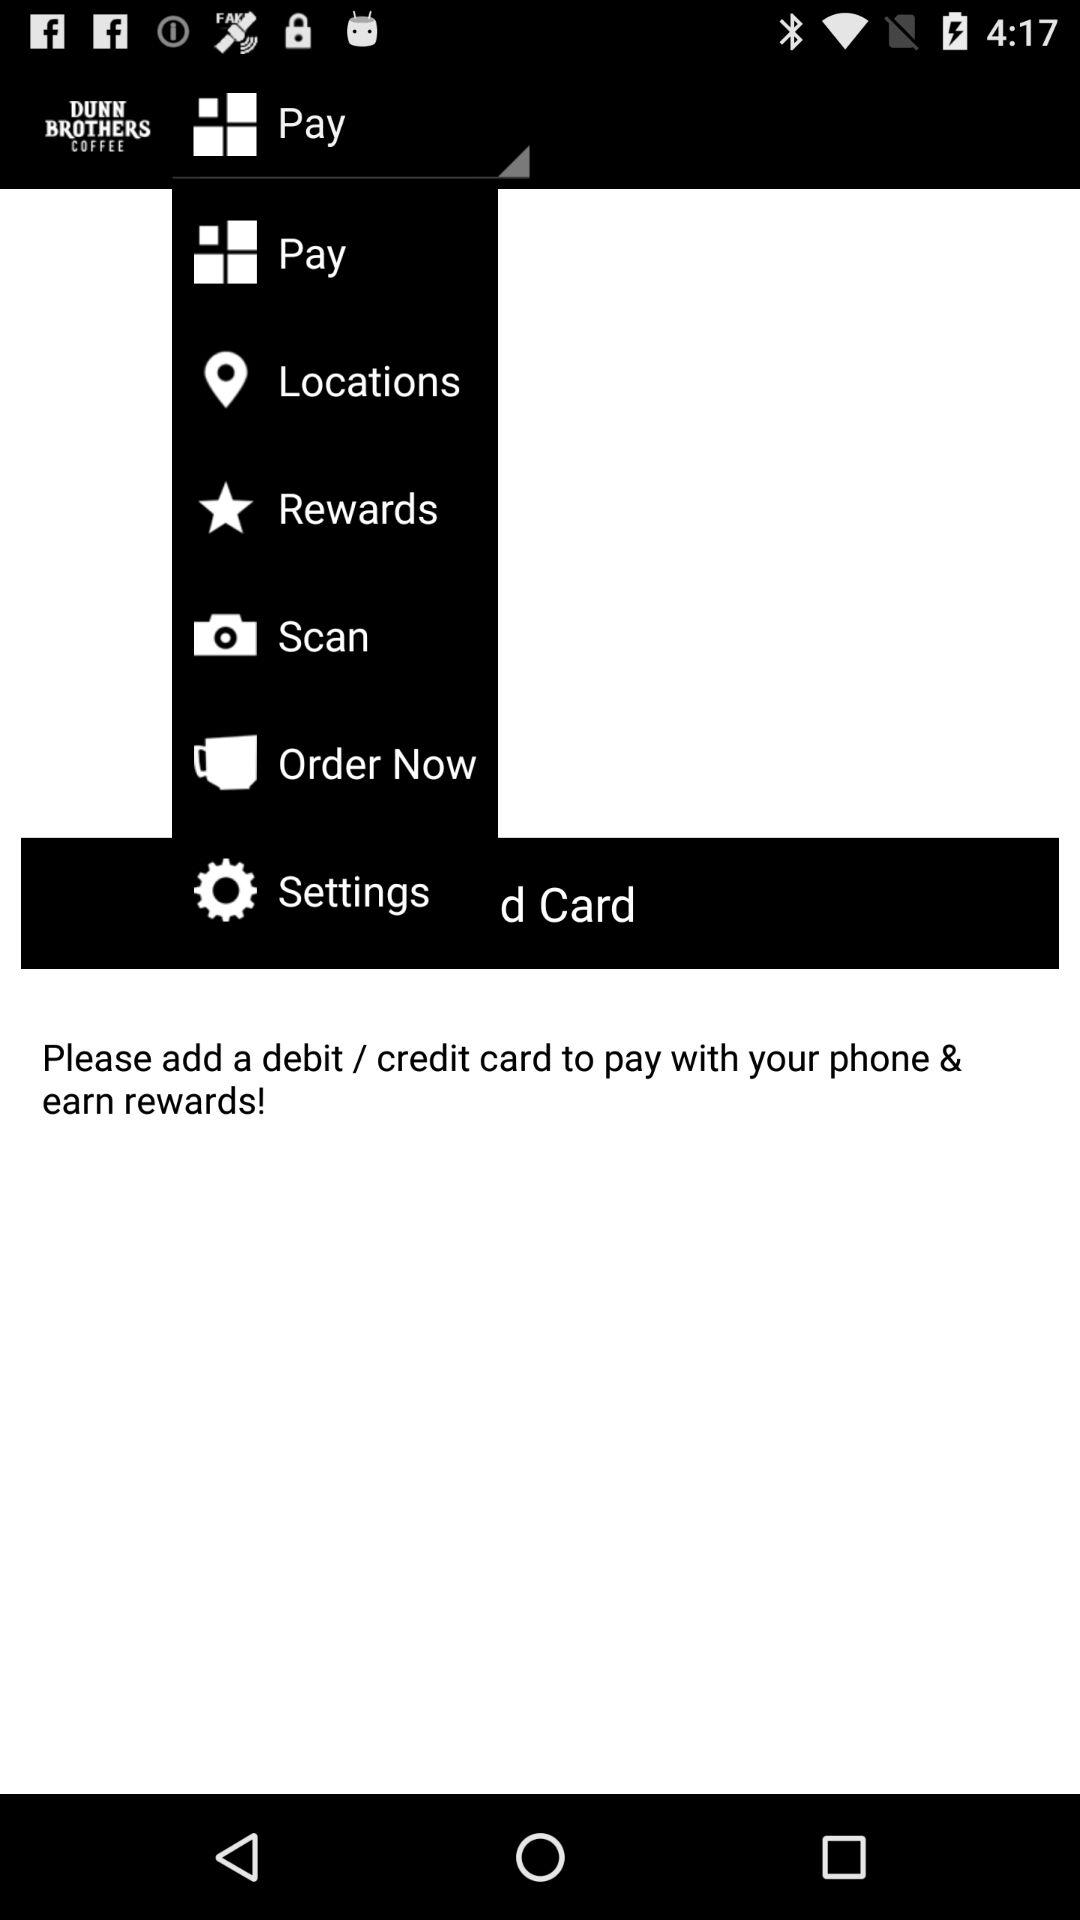What is the selected option from the drop-down list? The selected option is "Pay". 